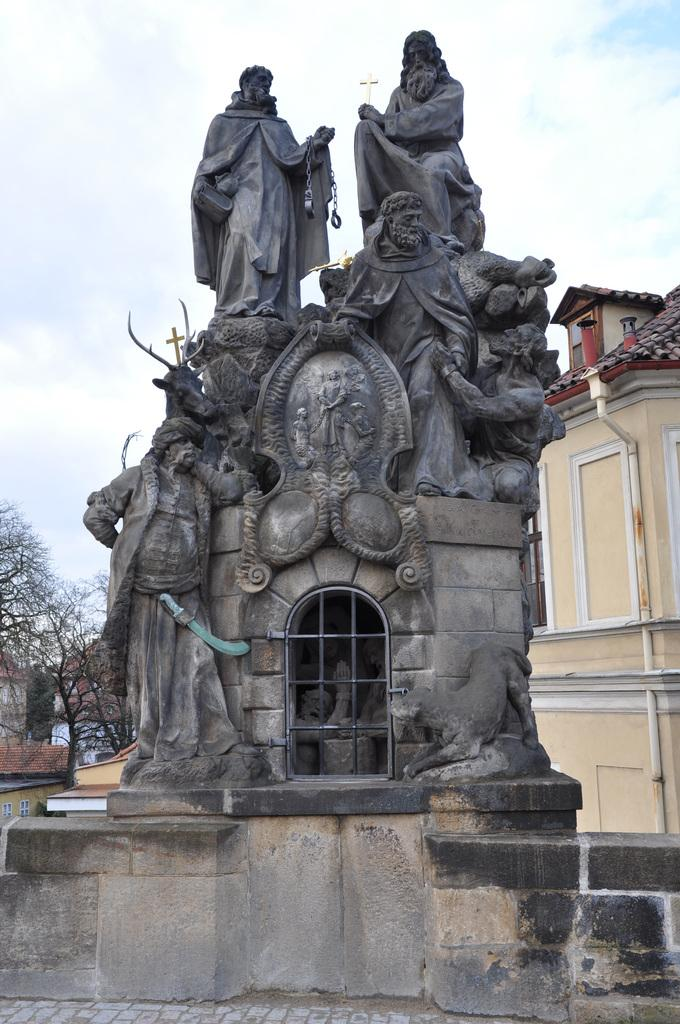What is the main subject of the image? There is a stone carving in the image. What can be seen in the background of the image? There is a building and a bare tree in the background of the image. What type of prose is written on the shelf in the image? There is no shelf or prose present in the image; it features a stone carving and a background with a building and a bare tree. 